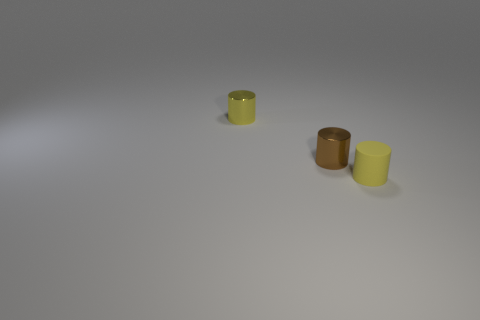What is the material of the other tiny cylinder that is the same color as the tiny rubber cylinder?
Offer a very short reply. Metal. What number of other objects are there of the same color as the matte cylinder?
Your answer should be very brief. 1. How many other things are there of the same material as the small brown object?
Your answer should be compact. 1. Do the brown metal cylinder and the yellow thing that is on the right side of the tiny yellow metal cylinder have the same size?
Give a very brief answer. Yes. The rubber cylinder is what color?
Your response must be concise. Yellow. There is a thing in front of the tiny metallic object in front of the small yellow metallic cylinder that is behind the small matte cylinder; what shape is it?
Your response must be concise. Cylinder. What is the material of the brown cylinder to the right of the tiny yellow thing on the left side of the brown thing?
Your response must be concise. Metal. Are there any other things that are the same shape as the yellow metallic object?
Offer a terse response. Yes. There is a small brown thing; what number of small cylinders are left of it?
Offer a very short reply. 1. Are any tiny metallic things visible?
Give a very brief answer. Yes. 